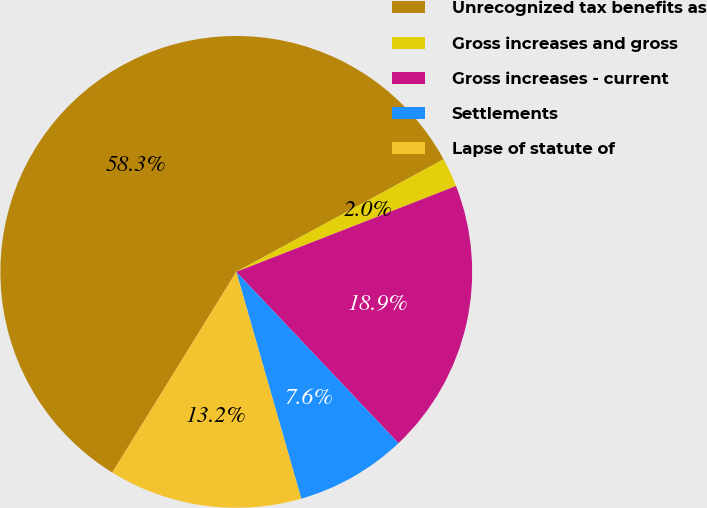<chart> <loc_0><loc_0><loc_500><loc_500><pie_chart><fcel>Unrecognized tax benefits as<fcel>Gross increases and gross<fcel>Gross increases - current<fcel>Settlements<fcel>Lapse of statute of<nl><fcel>58.28%<fcel>1.99%<fcel>18.87%<fcel>7.62%<fcel>13.25%<nl></chart> 